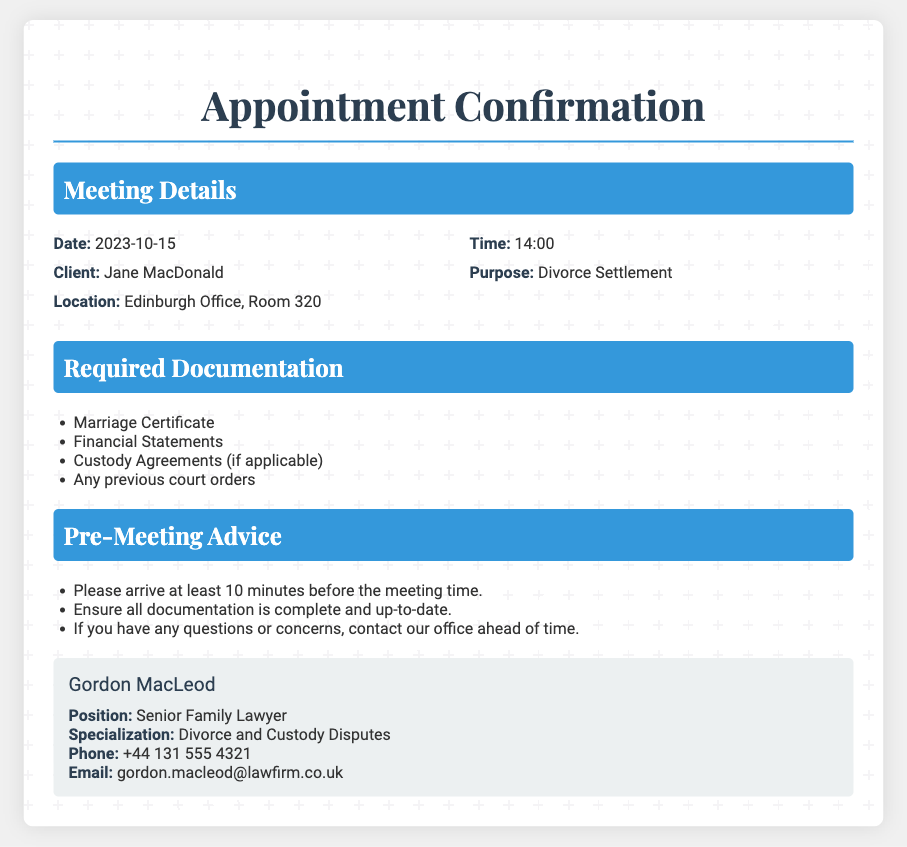What is the meeting date? The meeting date is explicitly stated in the document.
Answer: 2023-10-15 What is the time of the appointment? The document specifies the time for the appointment.
Answer: 14:00 Who is the client for this appointment? The client's name is mentioned in the meeting details section.
Answer: Jane MacDonald What is the purpose of the consultation? The document clearly outlines the purpose of the consultation.
Answer: Divorce Settlement What location is specified for the meeting? The location for the meeting is included in the appointment details.
Answer: Edinburgh Office, Room 320 What document is required related to marriage? The document lists the necessary downloads before the meeting.
Answer: Marriage Certificate How many required documents are listed? The document suggests a total number of required documents.
Answer: Four What is the lawyer's name? The lawyer's name is provided in the contact section of the document.
Answer: Gordon MacLeod What is the phone number listed for the lawyer? The lawyer's contact information includes a phone number.
Answer: +44 131 555 4321 